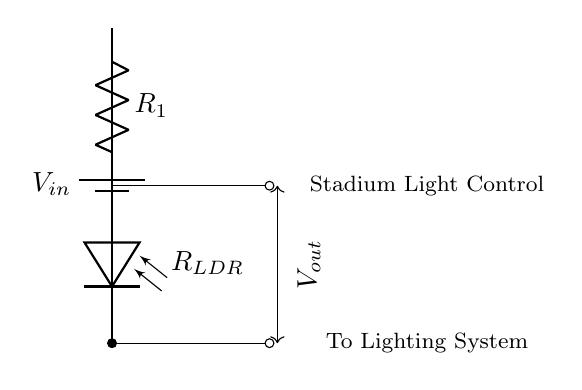What is the type of photodiode used in the circuit? The circuit uses an LDR (Light Dependent Resistor) as the photodiode, which adjusts the resistance based on light intensity.
Answer: Light Dependent Resistor What does Vout represent in this circuit? Vout is the voltage measured across the LDR, which controls the output to adjust lighting based on the ambient light conditions during the match.
Answer: Voltage across LDR What is the function of R1 in the circuit? R1 acts as a series resistor in the voltage divider configuration, affecting the voltage output (Vout) based on its resistance value compared to the LDR.
Answer: Series resistor How many components are there in the circuit? The circuit includes three components: a battery, a resistor (R1), and a photodiode (LDR). Summing these provides a total count.
Answer: Three What happens to Vout when ambient light increases? As ambient light increases, the resistance of the LDR decreases, which causes Vout to rise due to the voltage divider effect, resulting in brighter stadium lights.
Answer: Vout increases What is the main purpose of this circuit? The primary purpose of the circuit is to automatically adjust stadium lighting based on changing light conditions, ensuring optimal visibility during matches.
Answer: Automatic lighting adjustment What type of circuit is this? This is a voltage divider circuit, specifically designed to vary the output voltage based on the light-dependent resistance of the LDR.
Answer: Voltage divider circuit 